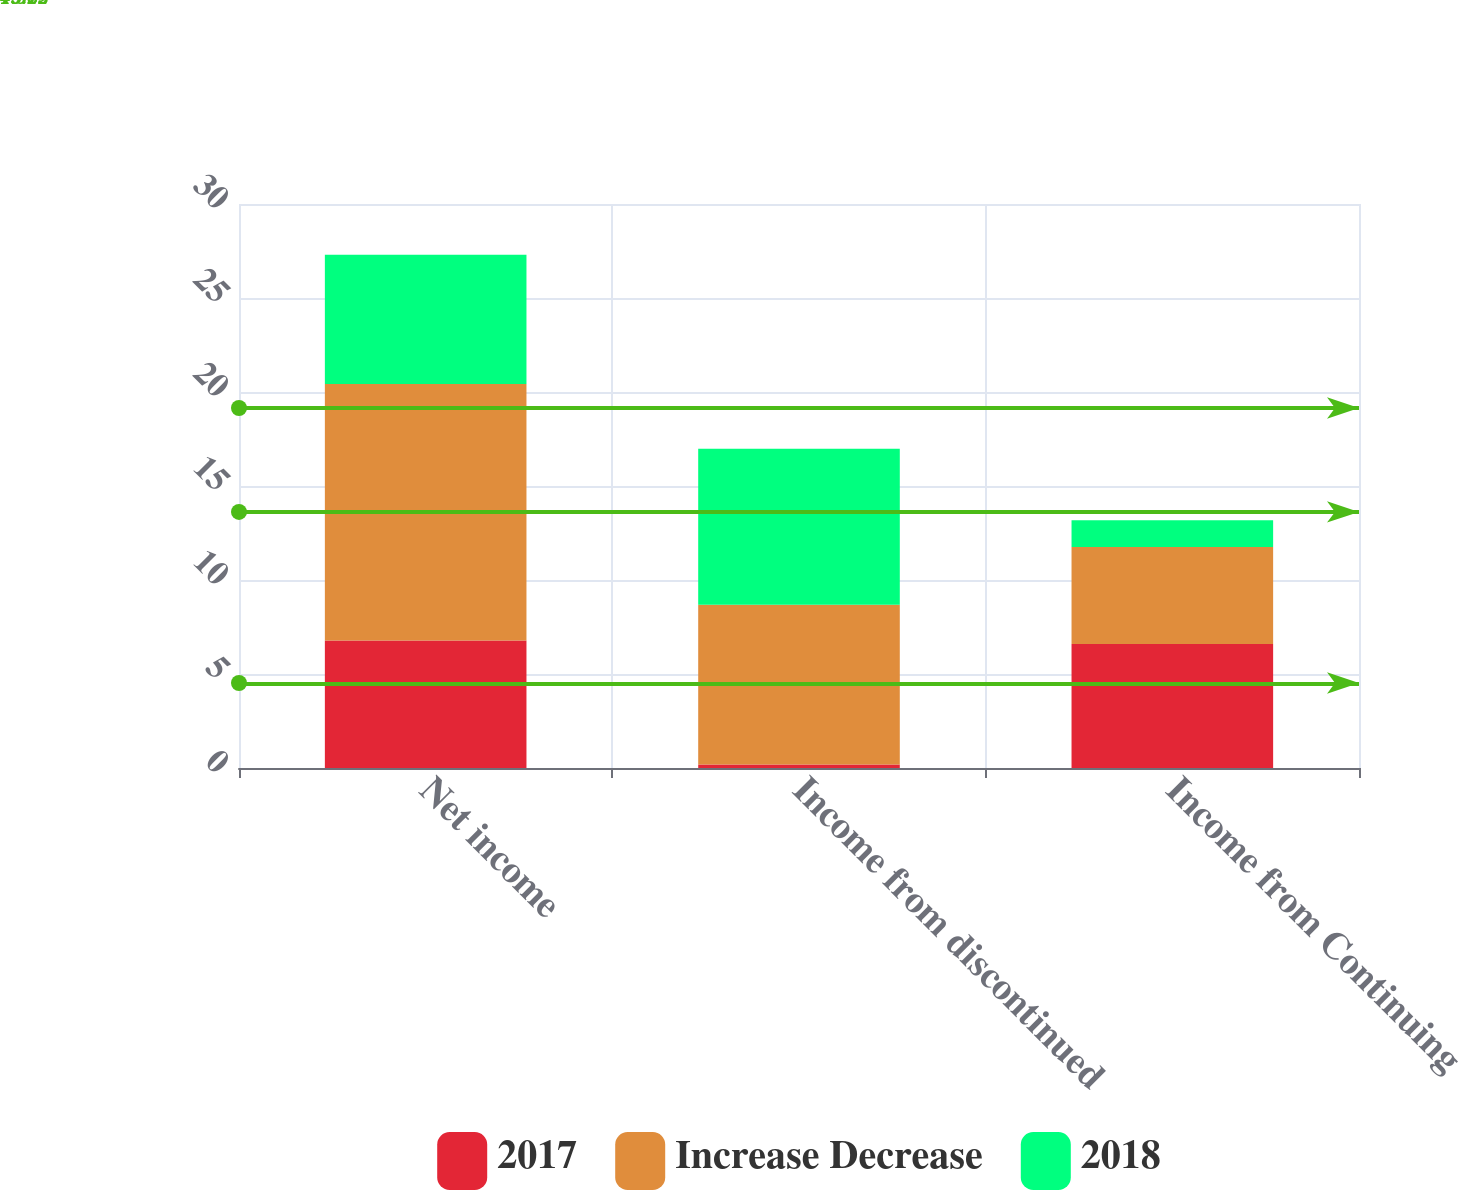Convert chart. <chart><loc_0><loc_0><loc_500><loc_500><stacked_bar_chart><ecel><fcel>Net income<fcel>Income from discontinued<fcel>Income from Continuing<nl><fcel>2017<fcel>6.78<fcel>0.19<fcel>6.59<nl><fcel>Increase Decrease<fcel>13.65<fcel>8.49<fcel>5.16<nl><fcel>2018<fcel>6.87<fcel>8.3<fcel>1.43<nl></chart> 